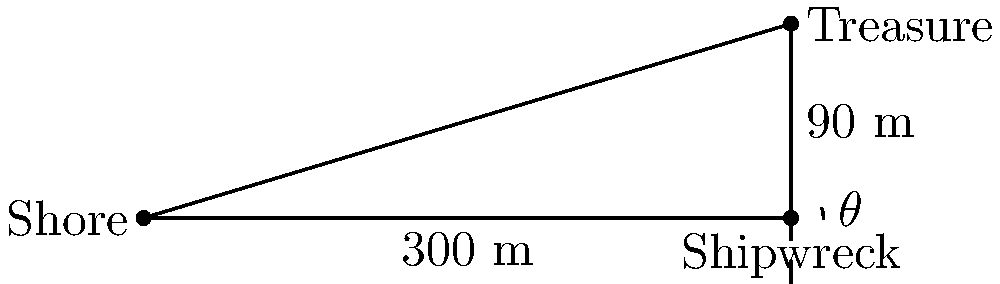A sunken treasure chest lies 90 meters deep in the sea, 300 meters away from the shore. What is the angle of descent $\theta$ from the surface of the water to the treasure chest? To find the angle of descent $\theta$, we need to use trigonometry. Let's approach this step-by-step:

1) We have a right triangle where:
   - The adjacent side (distance from shore to shipwreck) is 300 meters
   - The opposite side (depth of the treasure) is 90 meters

2) We need to find the angle $\theta$ between the hypotenuse and the adjacent side.

3) In a right triangle, tangent of an angle is the ratio of the opposite side to the adjacent side:

   $$\tan(\theta) = \frac{\text{opposite}}{\text{adjacent}} = \frac{90}{300} = 0.3$$

4) To find $\theta$, we need to take the inverse tangent (arctangent) of this ratio:

   $$\theta = \arctan(0.3)$$

5) Using a calculator or trigonometric tables:

   $$\theta \approx 16.70^\circ$$

6) Rounding to two decimal places:

   $$\theta \approx 16.70^\circ$$

This angle represents the slope at which the treasure chest descended from the surface of the water to its resting place on the seafloor.
Answer: $16.70^\circ$ 